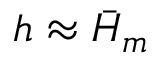<formula> <loc_0><loc_0><loc_500><loc_500>h \approx \bar { H } _ { m }</formula> 